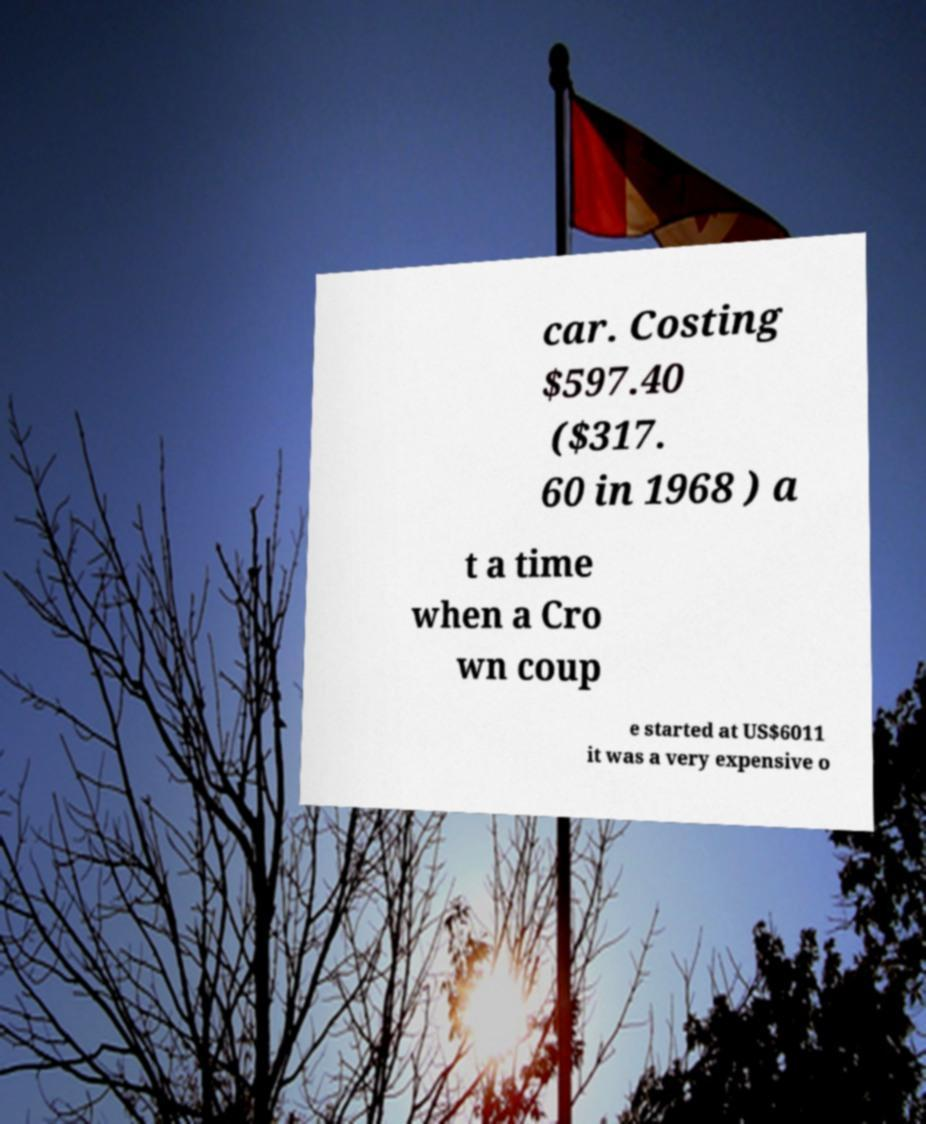Please read and relay the text visible in this image. What does it say? car. Costing $597.40 ($317. 60 in 1968 ) a t a time when a Cro wn coup e started at US$6011 it was a very expensive o 